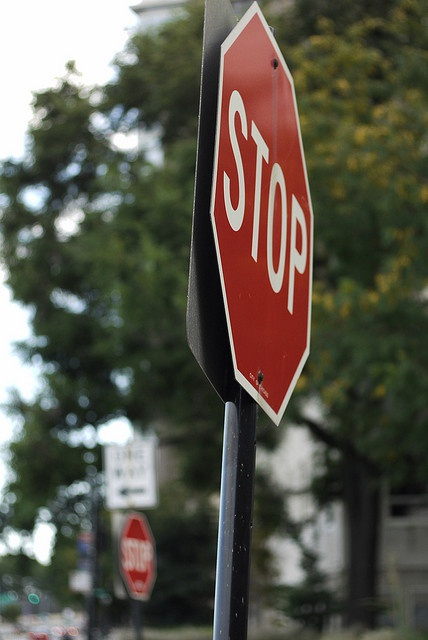Describe the objects in this image and their specific colors. I can see stop sign in white, maroon, brown, and lightgray tones and stop sign in white, brown, gray, and darkgray tones in this image. 